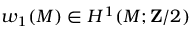Convert formula to latex. <formula><loc_0><loc_0><loc_500><loc_500>w _ { 1 } ( M ) \in H ^ { 1 } ( M ; Z / 2 )</formula> 